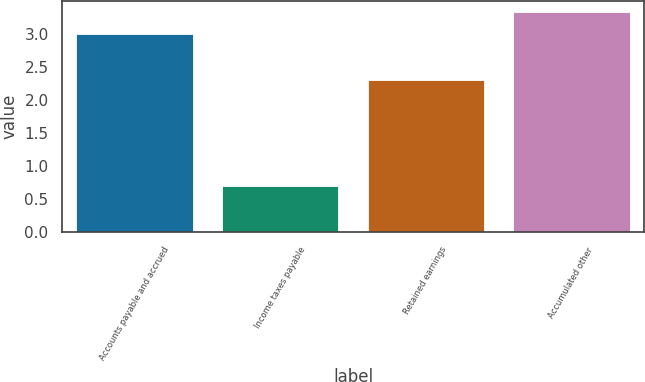Convert chart to OTSL. <chart><loc_0><loc_0><loc_500><loc_500><bar_chart><fcel>Accounts payable and accrued<fcel>Income taxes payable<fcel>Retained earnings<fcel>Accumulated other<nl><fcel>3<fcel>0.7<fcel>2.3<fcel>3.33<nl></chart> 